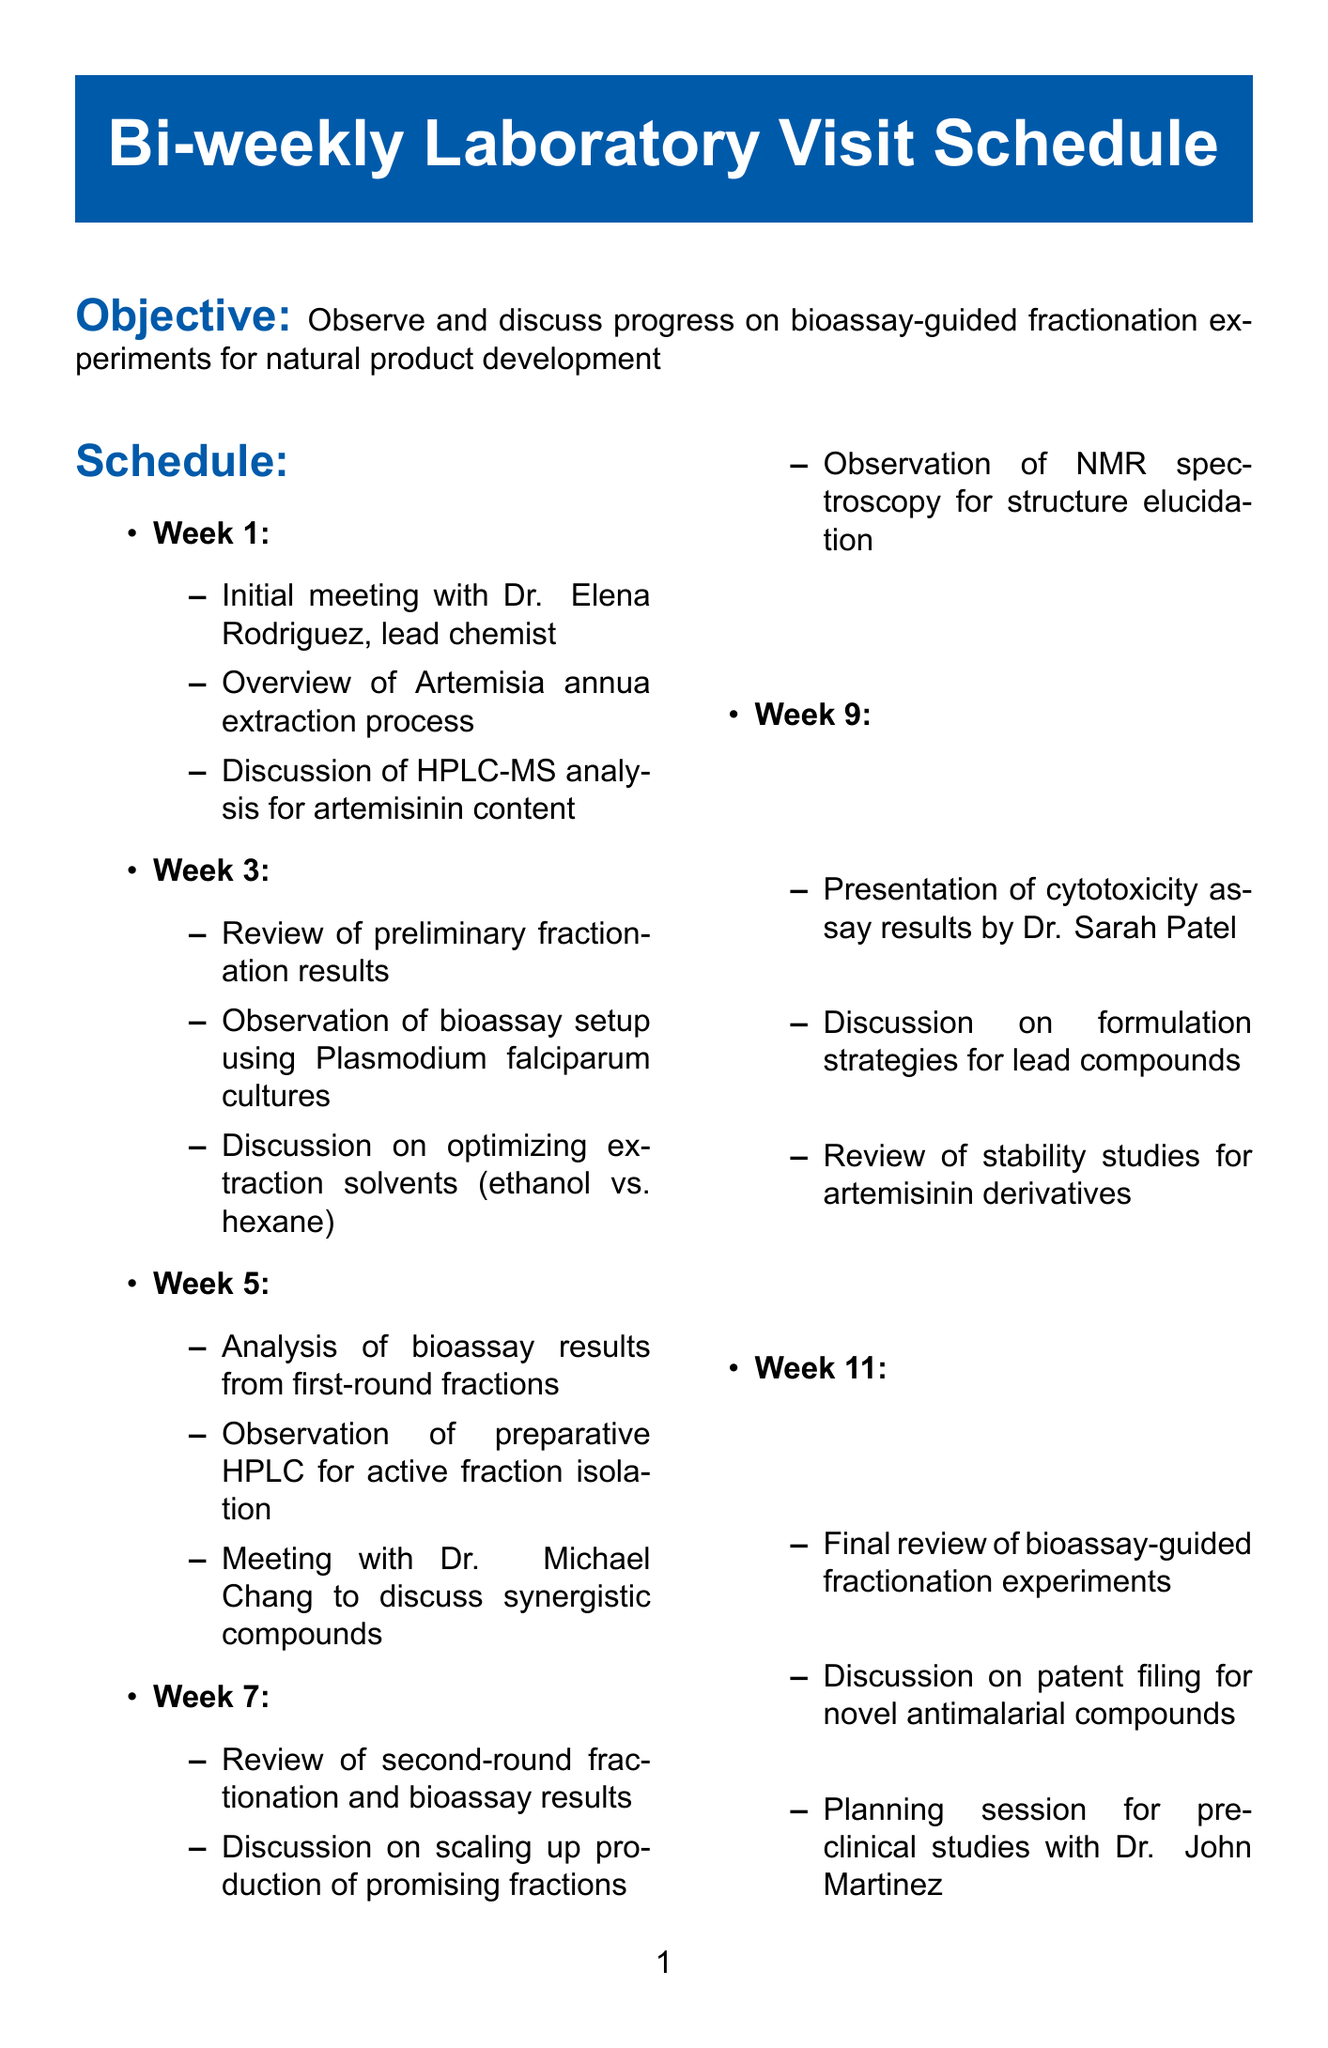What is the objective of the laboratory visits? The objective is to observe and discuss progress on bioassay-guided fractionation experiments for natural product development.
Answer: Observe and discuss progress on bioassay-guided fractionation experiments for natural product development Who is the lead chemist? The document lists Dr. Elena Rodriguez as the lead chemist.
Answer: Dr. Elena Rodriguez In which week is the presentation of cytotoxicity assay results scheduled? The presentation of cytotoxicity assay results by Dr. Sarah Patel is scheduled for week 9.
Answer: Week 9 What analysis is discussed in week 1? An overview of the Artemisia annua extraction process is discussed in week 1.
Answer: Overview of Artemisia annua extraction process What equipment is used for structure elucidation? The Bruker AVANCE III HD 600 MHz NMR spectrometer is used for structure elucidation.
Answer: Bruker AVANCE III HD 600 MHz NMR spectrometer How many weeks are included in the schedule? There are eleven weeks included in the schedule.
Answer: Eleven Which parasite strain is used for the bioassay? The bioassay details indicate that the strain used is Plasmodium falciparum 3D7.
Answer: Plasmodium falciparum 3D7 What discussion takes place in week 7? In week 7, there is a discussion on scaling up production of promising fractions.
Answer: Discussion on scaling up production of promising fractions Who is the pharmacologist listed in the document? Dr. Michael Chang is the pharmacologist mentioned in the document.
Answer: Dr. Michael Chang 